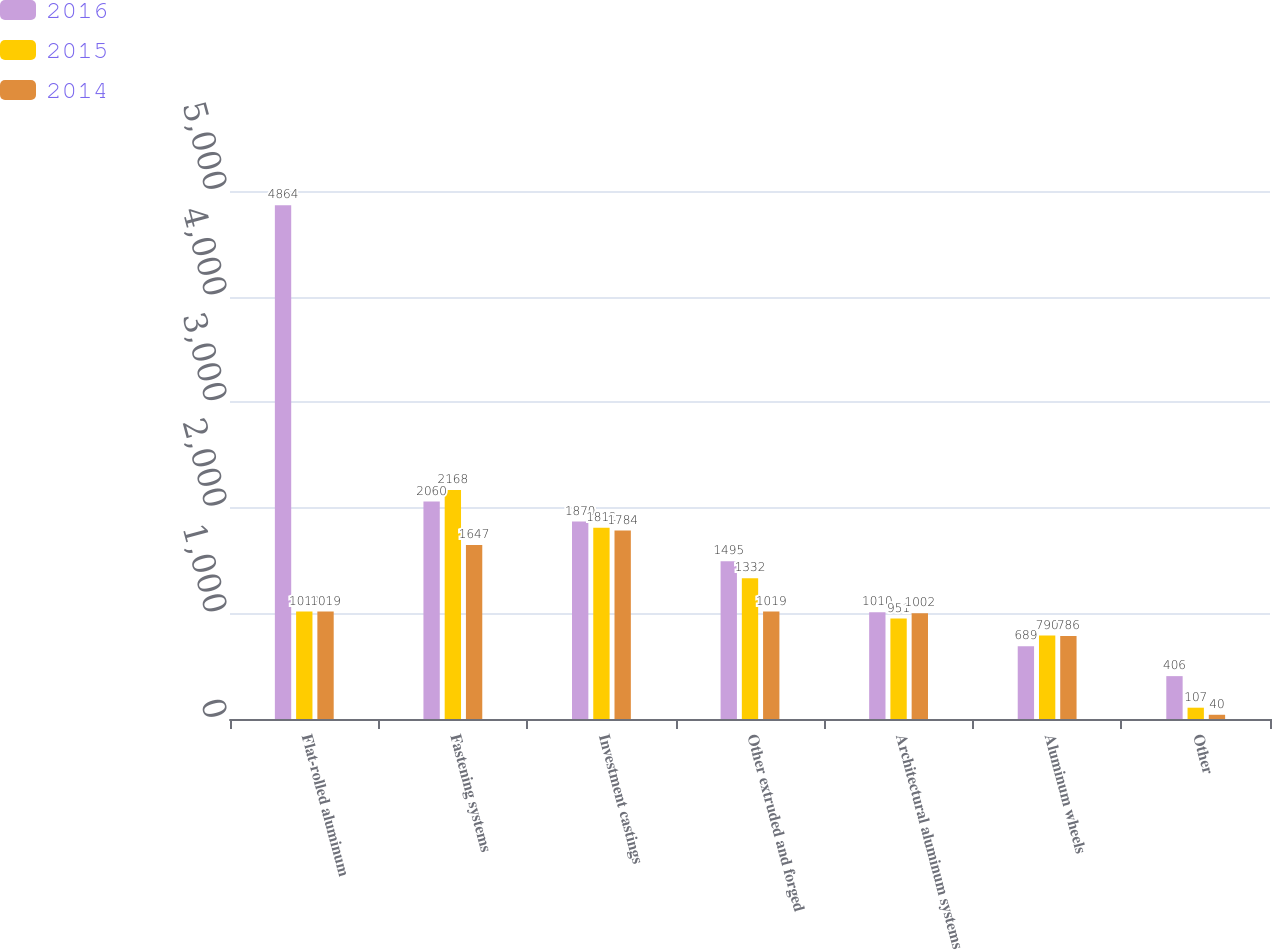<chart> <loc_0><loc_0><loc_500><loc_500><stacked_bar_chart><ecel><fcel>Flat-rolled aluminum<fcel>Fastening systems<fcel>Investment castings<fcel>Other extruded and forged<fcel>Architectural aluminum systems<fcel>Aluminum wheels<fcel>Other<nl><fcel>2016<fcel>4864<fcel>2060<fcel>1870<fcel>1495<fcel>1010<fcel>689<fcel>406<nl><fcel>2015<fcel>1019<fcel>2168<fcel>1812<fcel>1332<fcel>951<fcel>790<fcel>107<nl><fcel>2014<fcel>1019<fcel>1647<fcel>1784<fcel>1019<fcel>1002<fcel>786<fcel>40<nl></chart> 